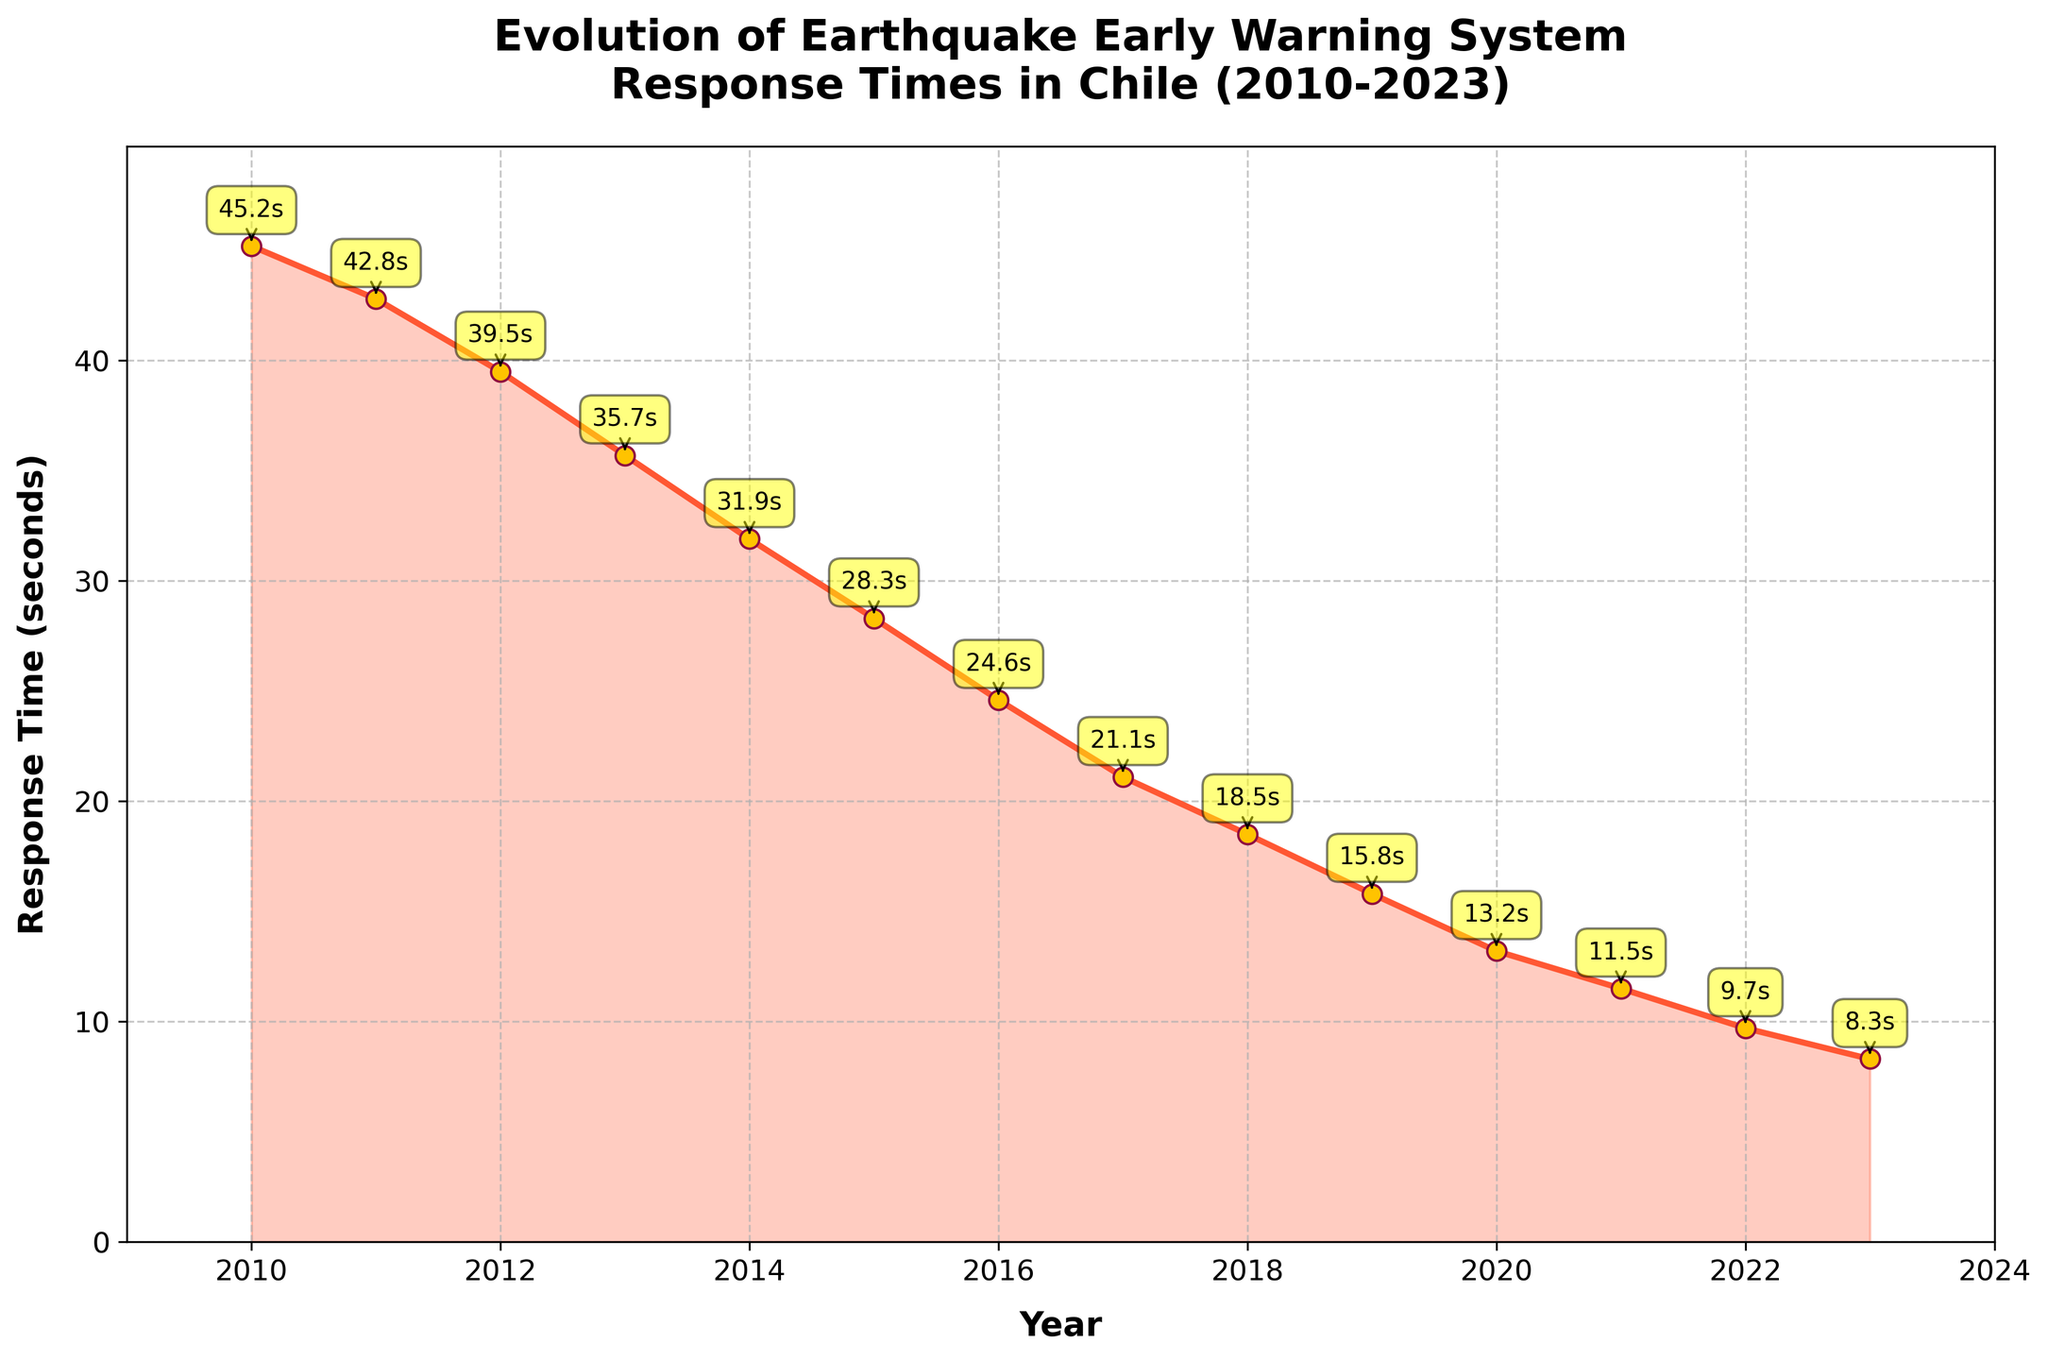What's the trend in the response times from 2010 to 2023? The response times show a clear decreasing trend from 2010 to 2023, indicating improvements in the Earthquake Early Warning System over the years.
Answer: Decreasing In which year did the response time fall below 20 seconds for the first time? By looking at the line chart, the response time first falls below 20 seconds in the year 2018.
Answer: 2018 What was the response time in 2015? We can observe from the line chart that the response time in 2015 is marked as 28.3 seconds.
Answer: 28.3 seconds Which year shows the greatest improvement in response time compared to the previous year? The greatest improvement would be the year with the largest decrease in response time. Comparing year-by-year, from 2014 to 2015, the response time dropped by 3.6 seconds (31.9 to 28.3). Other decreases are smaller.
Answer: 2014 to 2015 By how many seconds did the response time improve from 2010 to 2023? Subtracting the response time in 2023 from that in 2010 gives the overall improvement: 45.2 - 8.3 = 36.9 seconds.
Answer: 36.9 seconds Which two consecutive years had the smallest change in response time? By comparing the year-to-year changes, the smallest change occurred between 2022 and 2023 (9.7 to 8.3), which is a change of 1.4 seconds.
Answer: 2022 to 2023 In which year did the response time first drop below 30 seconds? Observing the trend on the plot, the first year the response time drops below 30 seconds is in 2015.
Answer: 2015 What is the average response time from 2010 to 2023? To find the average, sum the response times and divide by the number of years. Total sum = 372.8 seconds over 14 years, so the average is 372.8 / 14 = 26.63 seconds.
Answer: 26.63 seconds What visual indicator is used to show the data points on the line chart? The data points are marked with circular markers that are colored yellow with a red outline.
Answer: Yellow circles 